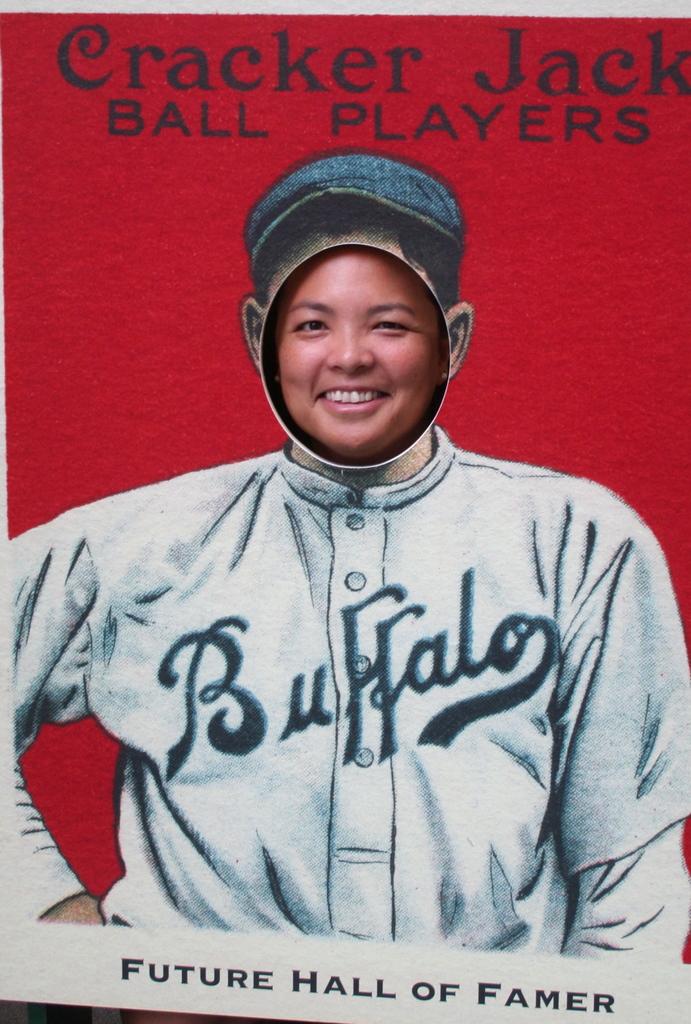What town is the uniform for?
Offer a terse response. Buffalo. What is the tag line on the bottom?
Your response must be concise. Future hall of famer. 